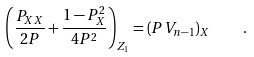<formula> <loc_0><loc_0><loc_500><loc_500>\left ( \frac { P _ { X X } } { 2 P } + \frac { 1 - P _ { X } ^ { 2 } } { 4 P ^ { 2 } } \right ) _ { Z _ { 1 } } = \left ( P V _ { n - 1 } \right ) _ { X } \quad .</formula> 